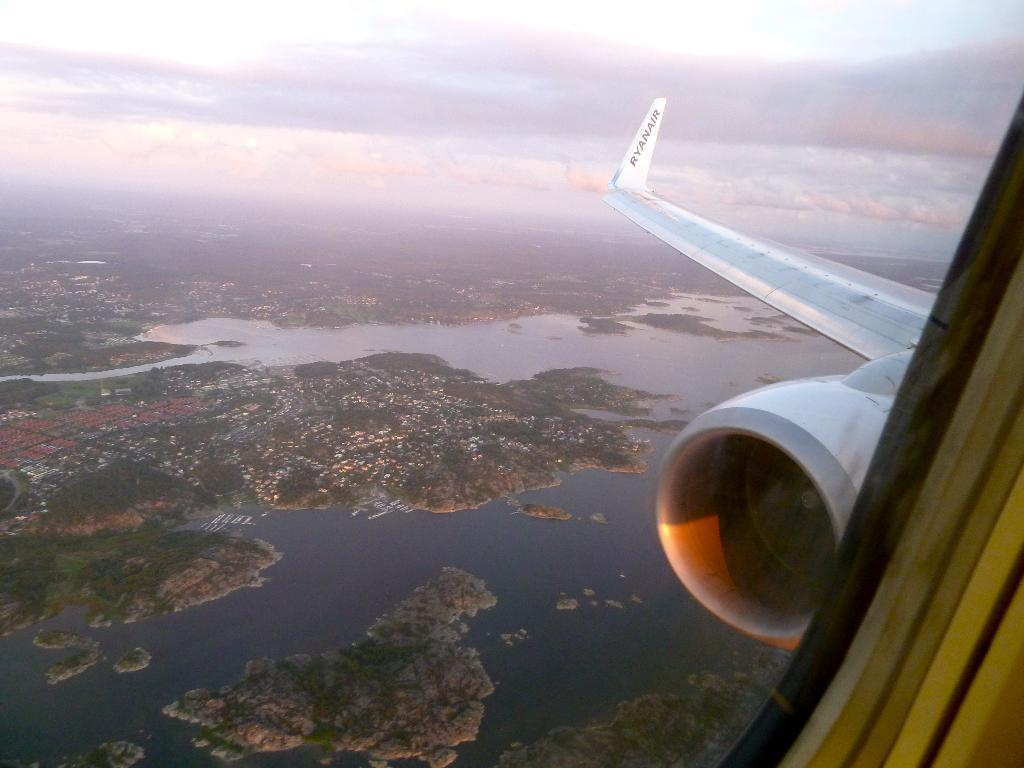What part of an airplane can be seen in the image? The wing and engine of an airplane are visible in the image. What is located beneath the airplane in the image? Trees and water are present beneath the airplane in the image. How many ants can be seen carrying a kite in the image? There are no ants or kites present in the image. What type of car is parked near the water in the image? There is no car present in the image; it only features the wing and engine of an airplane, trees, and water. 